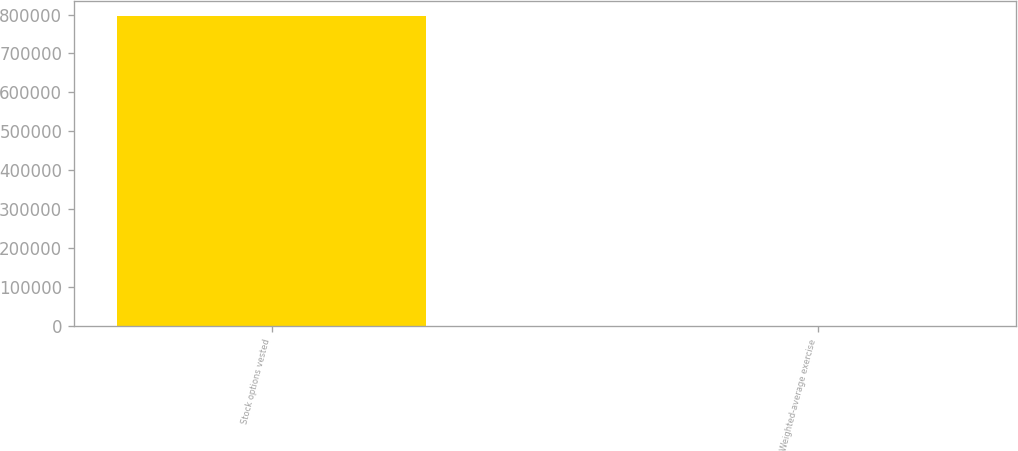Convert chart. <chart><loc_0><loc_0><loc_500><loc_500><bar_chart><fcel>Stock options vested<fcel>Weighted-average exercise<nl><fcel>795566<fcel>46.86<nl></chart> 